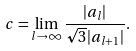<formula> <loc_0><loc_0><loc_500><loc_500>c = \lim _ { l \rightarrow \infty } \frac { | a _ { l } | } { \sqrt { 3 } | a _ { l + 1 } | } .</formula> 